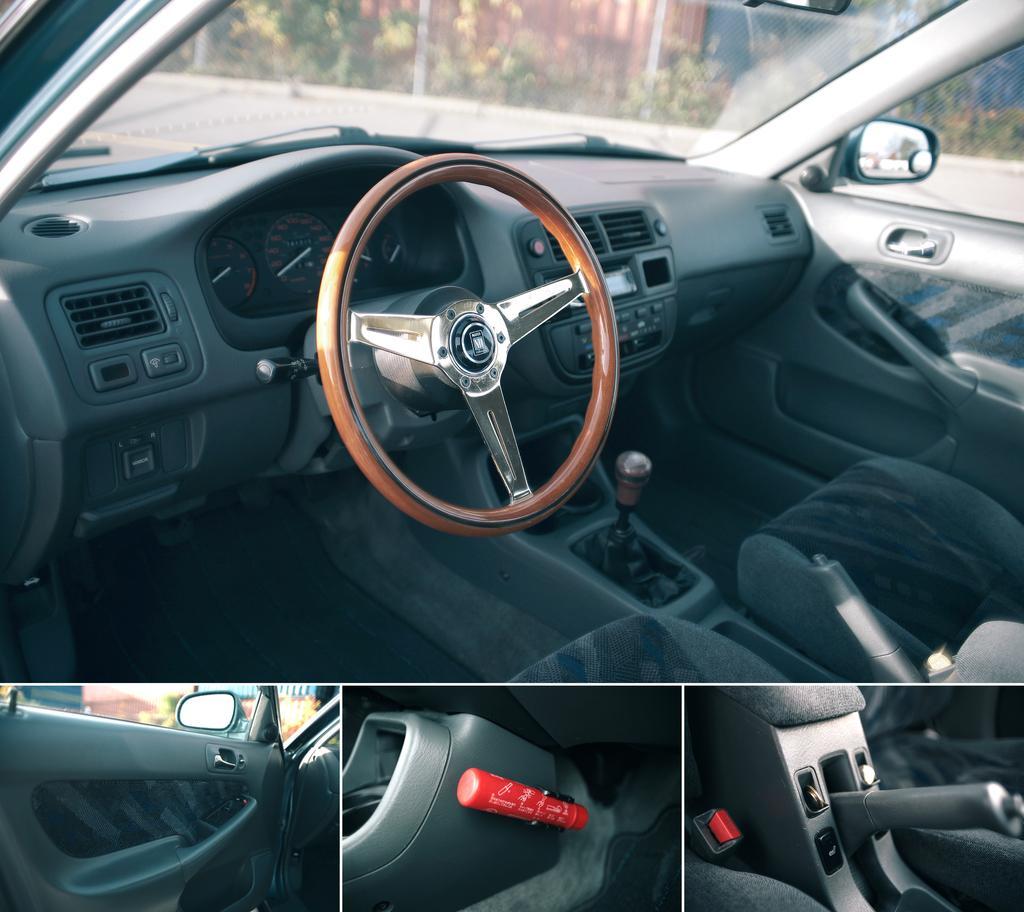Please provide a concise description of this image. In the picture there is an inside view of a car present, there are glass windows present, there are plants. 